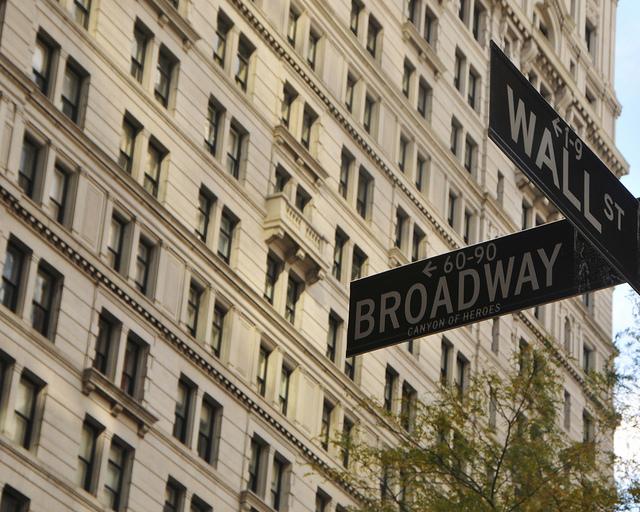Are all the buildings white?
Short answer required. Yes. How many windows?
Keep it brief. 40. How many stories is the building on the left?
Give a very brief answer. 13. Is this a building in New York?
Short answer required. Yes. What country is this?
Keep it brief. Usa. What intersection is this?
Give a very brief answer. Broadway and wall street. 